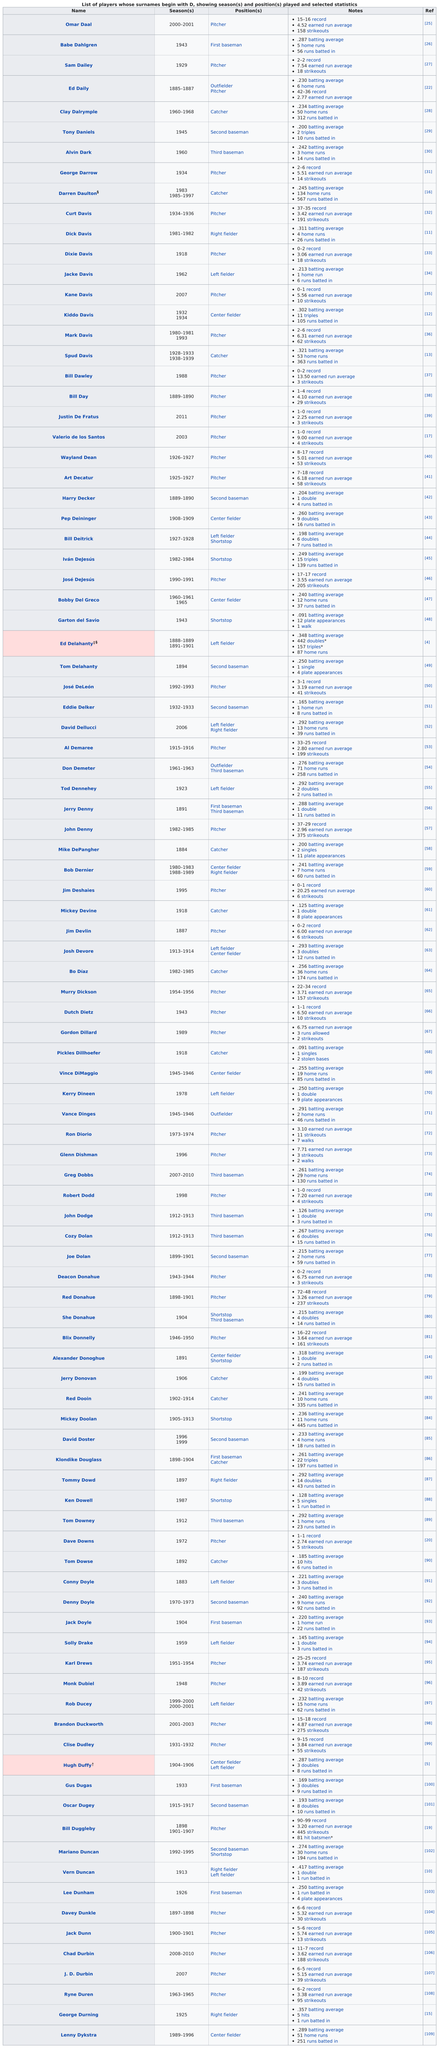Point out several critical features in this image. There are 12 left fielders on the list. Darren Daulton had 567 runs batted in. The total number of catchers whose surname begins with 'D' is 11. The last position on the chart is center fielder. Only player Sam Dailey from the 1929 season has a surname that starts with the letter D 